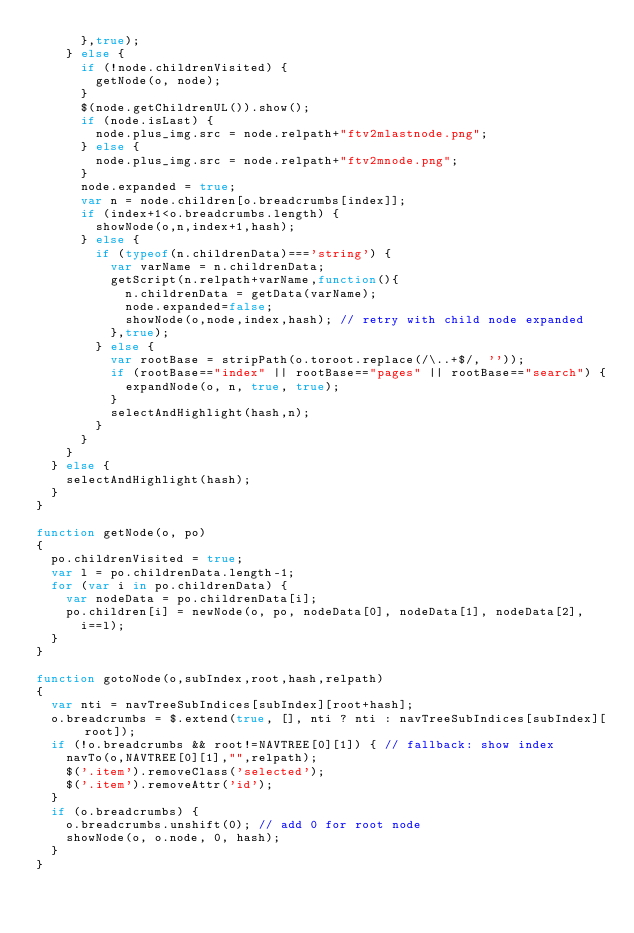<code> <loc_0><loc_0><loc_500><loc_500><_JavaScript_>      },true);
    } else {
      if (!node.childrenVisited) {
        getNode(o, node);
      }
      $(node.getChildrenUL()).show();
      if (node.isLast) {
        node.plus_img.src = node.relpath+"ftv2mlastnode.png";
      } else {
        node.plus_img.src = node.relpath+"ftv2mnode.png";
      }
      node.expanded = true;
      var n = node.children[o.breadcrumbs[index]];
      if (index+1<o.breadcrumbs.length) {
        showNode(o,n,index+1,hash);
      } else {
        if (typeof(n.childrenData)==='string') {
          var varName = n.childrenData;
          getScript(n.relpath+varName,function(){
            n.childrenData = getData(varName);
            node.expanded=false;
            showNode(o,node,index,hash); // retry with child node expanded
          },true);
        } else {
          var rootBase = stripPath(o.toroot.replace(/\..+$/, ''));
          if (rootBase=="index" || rootBase=="pages" || rootBase=="search") {
            expandNode(o, n, true, true);
          }
          selectAndHighlight(hash,n);
        }
      }
    }
  } else {
    selectAndHighlight(hash);
  }
}

function getNode(o, po)
{
  po.childrenVisited = true;
  var l = po.childrenData.length-1;
  for (var i in po.childrenData) {
    var nodeData = po.childrenData[i];
    po.children[i] = newNode(o, po, nodeData[0], nodeData[1], nodeData[2],
      i==l);
  }
}

function gotoNode(o,subIndex,root,hash,relpath)
{
  var nti = navTreeSubIndices[subIndex][root+hash];
  o.breadcrumbs = $.extend(true, [], nti ? nti : navTreeSubIndices[subIndex][root]);
  if (!o.breadcrumbs && root!=NAVTREE[0][1]) { // fallback: show index
    navTo(o,NAVTREE[0][1],"",relpath);
    $('.item').removeClass('selected');
    $('.item').removeAttr('id');
  }
  if (o.breadcrumbs) {
    o.breadcrumbs.unshift(0); // add 0 for root node
    showNode(o, o.node, 0, hash);
  }
}
</code> 